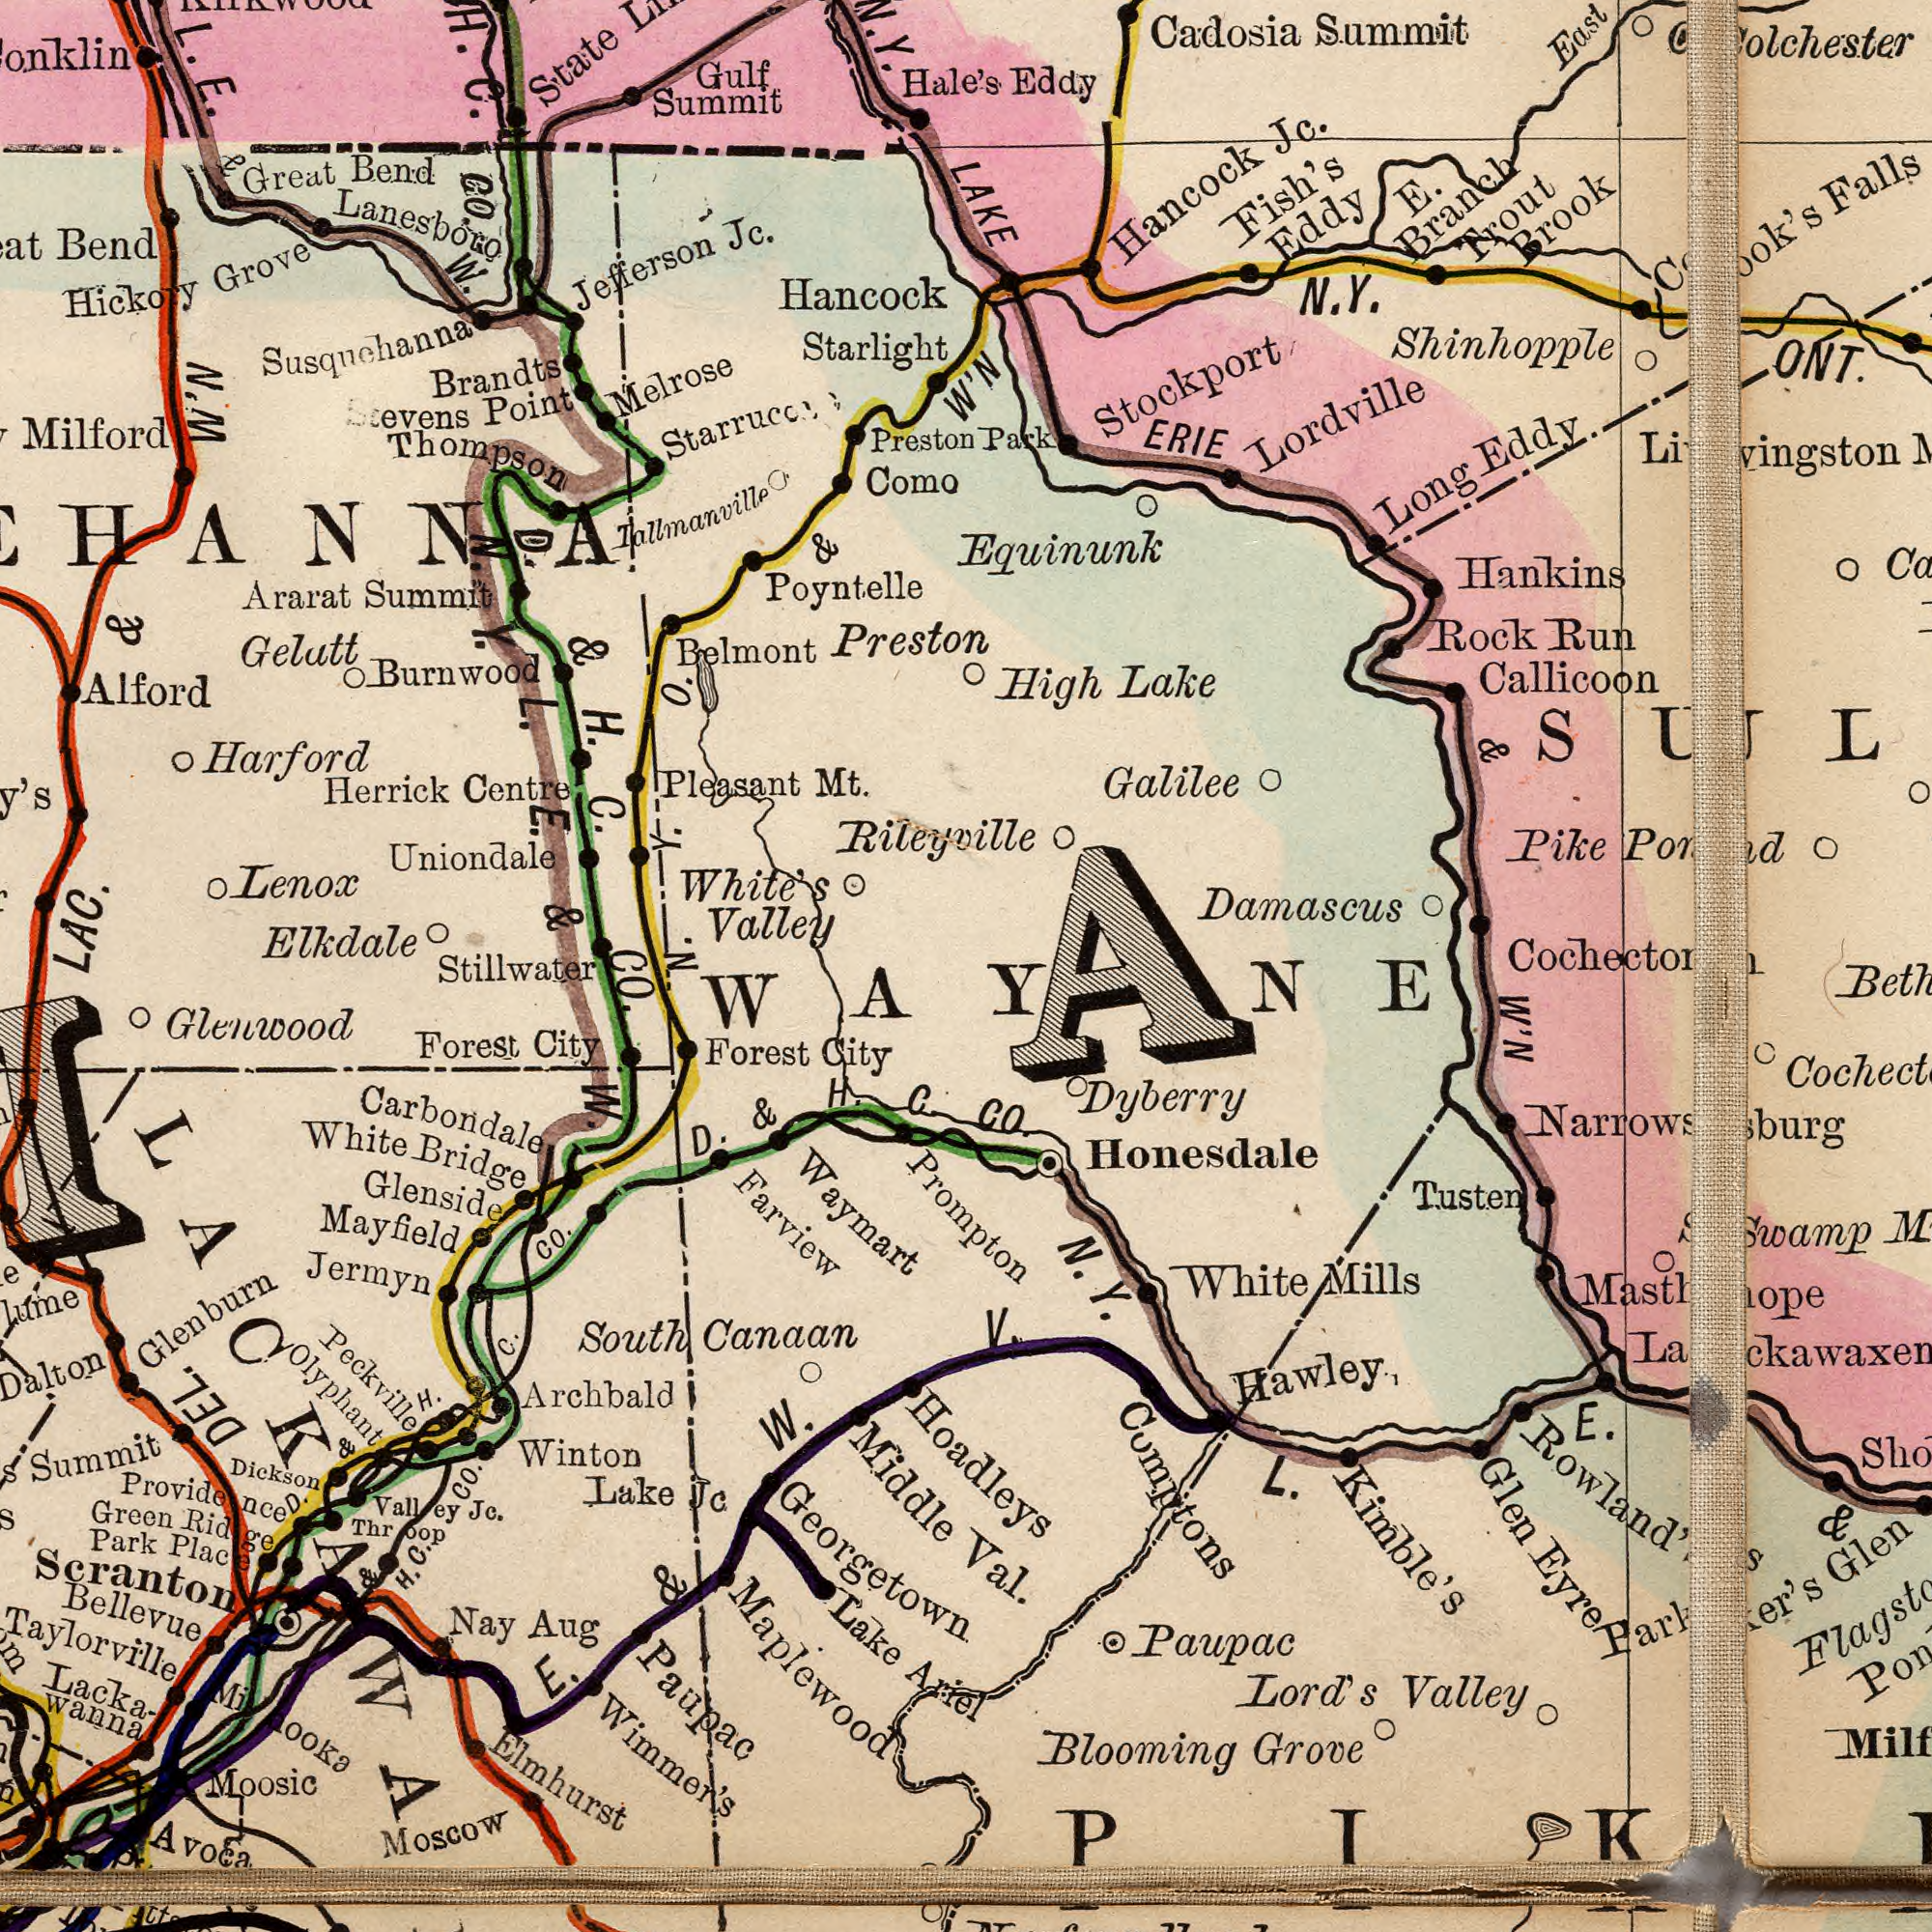What text is visible in the upper-right corner? Park Eddy W'N N.Y. Shinhopple Lordville Trout Brook Hancock Jc. Rock Run LAKE ERIE & Cadosia Summit High Lake East Galilee Long Eddy Pike Callicoon E. Branch Damascus Cook's Fish's Eddy ###olchester### Equinunk Hankins Stockport What text appears in the top-left area of the image? Uniondale Burnwood Herrick Centre Poyntelle Stevens Thompson H. C. CO. Harford Brandts Point ###Milford Jefferson Jc. L. E. & W. Melrose Pleasant Mt. Lenox Tallmanville Gelutt Bend Belmont Ararat Summit Hickory Grove Preston Gulf Summit Great Bend Como Preston White's Valley Rileyville LAC. & W'N Lanesboro Hale's Hancock Starlight State D. & H. C. Starrucc Susquchanna Y. O. & Alford Y. N. Y. L. E. & What text appears in the bottom-left area of the image? Elkdale DEL. CO. N. Elmhurst Wimmer's Glenwood Bellevue Maplewood Scranton Farview Moscow Glenside Moosic Jermyn Winton Lake Jc South Canaan Glenburn Providence Summit Green Ridg Forest City White Bridge Forest City Nay Aug Lacka wanna D. & H. C. CO. Carbondale Park Place Lake Ariel Throop Valley Jc. E. & W. Dickson Georgetown Waymart Avoca Prompton Olyphant H. C. CO. D. & H. C. Peckville Middle Mayfield Paupac Stillwater Archbald W. & LACKAWA What text is shown in the bottom-right quadrant? W'N V. CO. Val. Rowland's Hawley.<SUB>1</SUB> Comptons Masthpe Dyberry Blooming Grove Parker's Swamp Narrowsburg Paupac Lord's Valley N. Y. L. E. & Honesdale Hoadleys Tusten Glen Eyre Kimble's White Mills WAYNE 